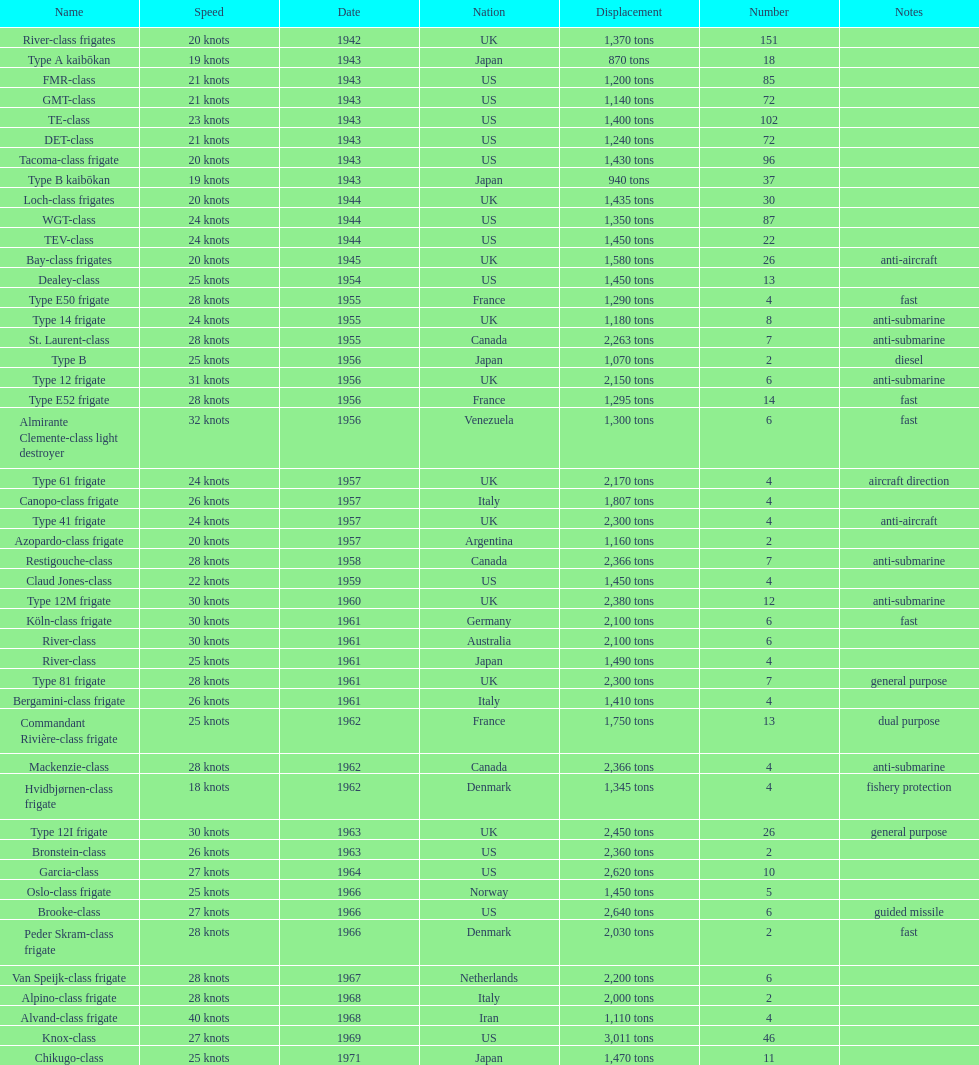What is the difference in speed for the gmt-class and the te-class? 2 knots. 